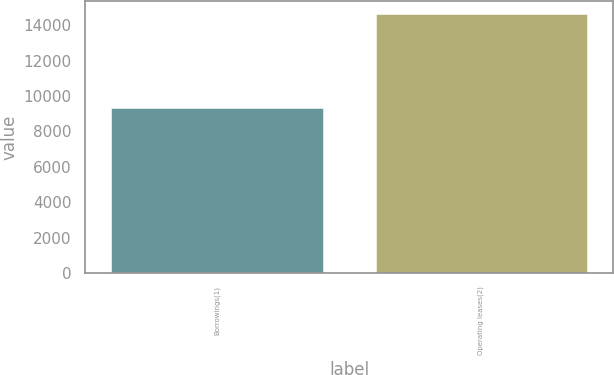<chart> <loc_0><loc_0><loc_500><loc_500><bar_chart><fcel>Borrowings(1)<fcel>Operating leases(2)<nl><fcel>9333<fcel>14644<nl></chart> 